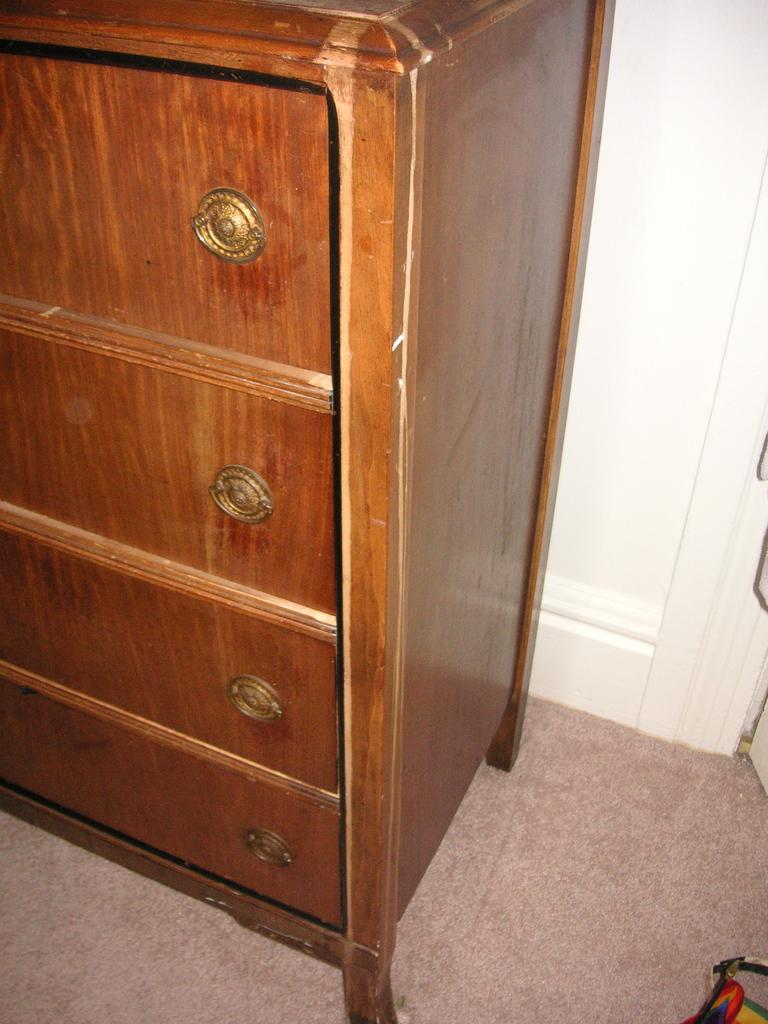What type of furniture is present in the image? There is a wooden shelf in the image. What is located near the wooden shelf? There is a wall near the shelf. What can be seen on the wooden shelf? There are round-shaped golden objects on the shelf. What type of juice is being served to the visitor in the image? There is no visitor or juice present in the image. How much money is visible on the shelf in the image? There is no money visible on the shelf in the image; only round-shaped golden objects are present. 